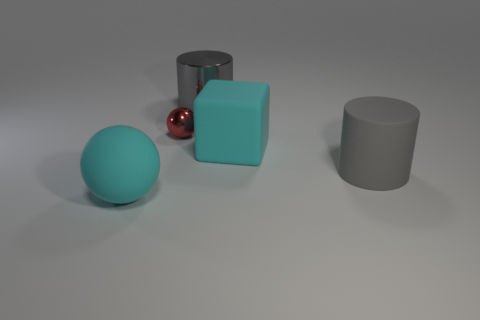How does the size of the red ball compare to the other objects? The red ball is smaller in size relative to the cyan cube, yet larger than the gray cylinder's base diameter. Its scale makes it stand out due to its reflective surface and contrasting color, adding visual interest to the composition. If the red ball was moved next to the gray cylinder, how would the composition of the image change? Placing the red ball next to the gray cylinder would create a grouping of similar shapes due to their rounded edges, and further emphasize the contrast in their textures and colors. It might also alter the visual balance of the scene, drawing the eye more to that grouping. 